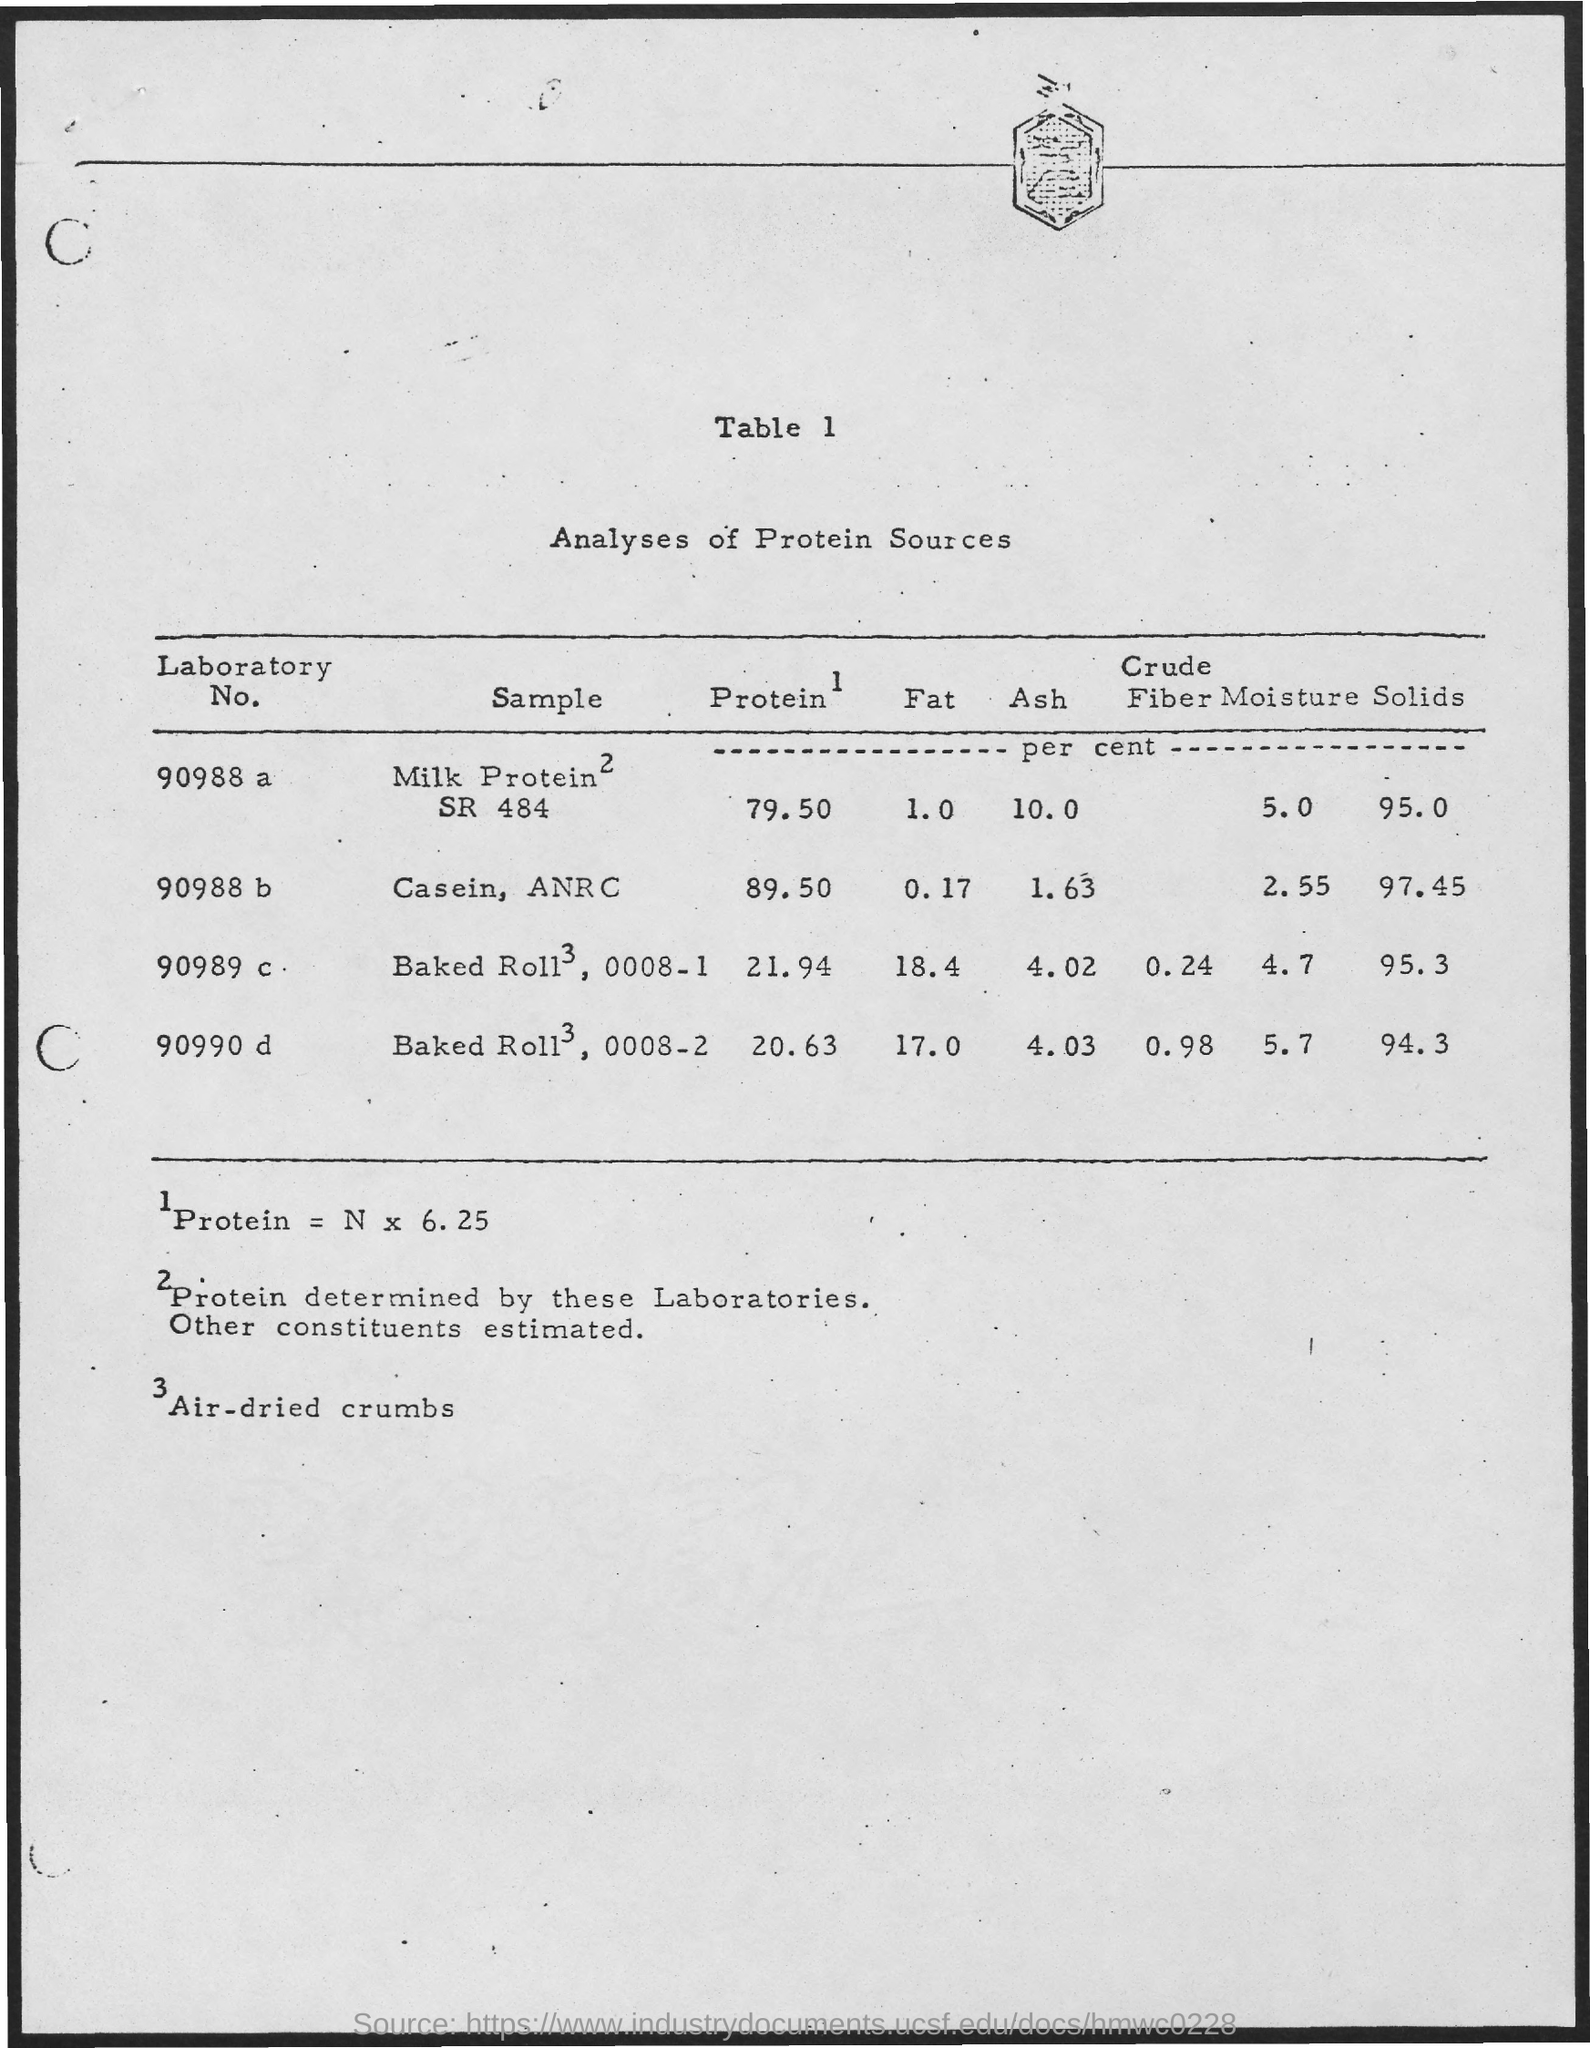What is the Sample for Laboratory No. 90988 a?
Your answer should be very brief. Milk Protein SR 484. What is the Protein for Laboratory No. 90988 a?
Keep it short and to the point. 79.50. What is the Fat for Laboratory No. 90988 a?
Your response must be concise. 1.0. What is the Ash for Laboratory No. 90988 a?
Your answer should be very brief. 10.0. What is the Sample for Laboratory No. 90988 b?
Provide a short and direct response. Casein ANRC. What is the Protein for Laboratory No. 90988 b?
Give a very brief answer. 89.50. What is the Fat for Laboratory No. 90988 b?
Your response must be concise. 0.17. What is the Ash for Laboratory No. 90988 b?
Your response must be concise. 1.63. What is the Sample for Laboratory No. 90988 c?
Your answer should be compact. Baked Roll, 0008-1. What is the name of the table?
Your response must be concise. Analyses of Protein Sources. 